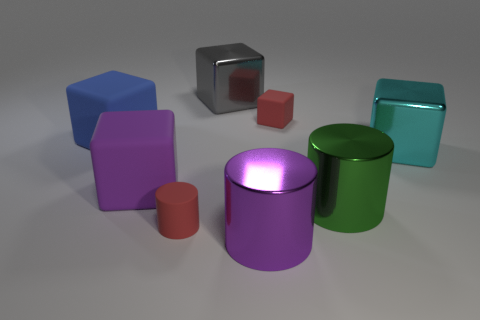Subtract all yellow blocks. Subtract all brown cylinders. How many blocks are left? 5 Add 1 tiny blue matte cubes. How many objects exist? 9 Subtract all blocks. How many objects are left? 3 Add 4 big purple rubber things. How many big purple rubber things are left? 5 Add 1 large yellow rubber spheres. How many large yellow rubber spheres exist? 1 Subtract 1 gray cubes. How many objects are left? 7 Subtract all big gray things. Subtract all big purple rubber cubes. How many objects are left? 6 